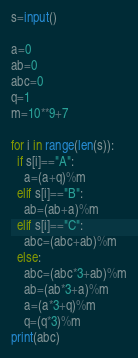Convert code to text. <code><loc_0><loc_0><loc_500><loc_500><_Python_>s=input()

a=0
ab=0
abc=0
q=1
m=10**9+7

for i in range(len(s)):
  if s[i]=="A":
    a=(a+q)%m
  elif s[i]=="B":
    ab=(ab+a)%m
  elif s[i]=="C":
    abc=(abc+ab)%m
  else:
    abc=(abc*3+ab)%m
    ab=(ab*3+a)%m
    a=(a*3+q)%m
    q=(q*3)%m
print(abc)
</code> 